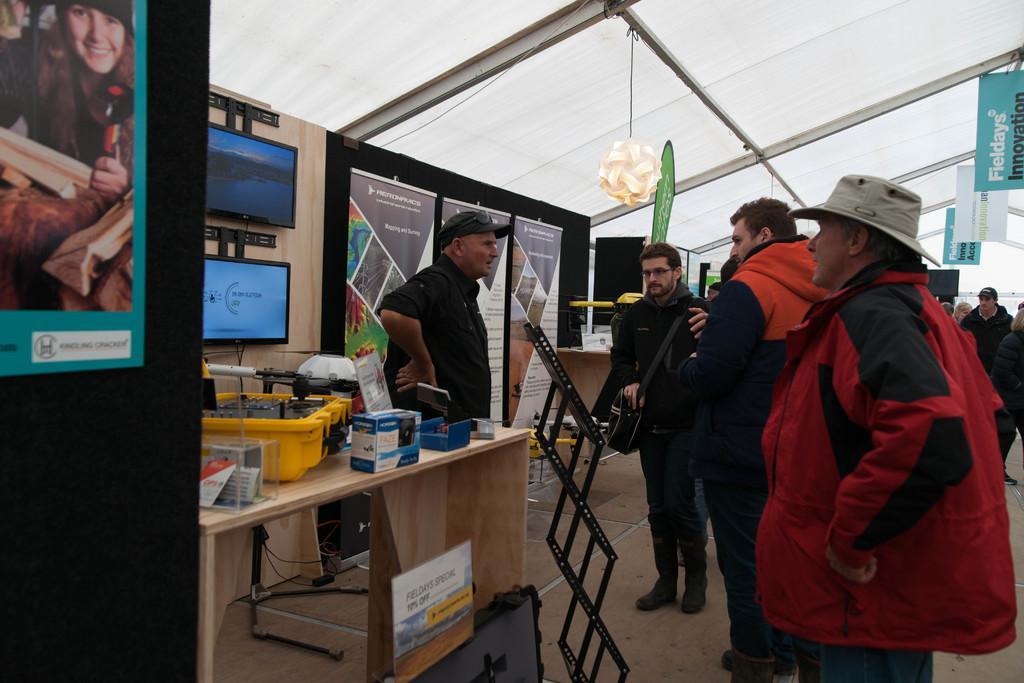Could you give a brief overview of what you see in this image? Here we can see a group of people standing and talking to themselves, the person the front is wearing hat, the person on the left is wearing a cap and we can see a table with so many things present on it and we can see monitors present and there are posters present here and there 